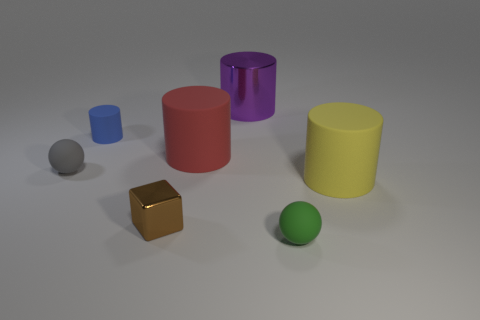Subtract all yellow cylinders. How many cylinders are left? 3 Add 1 gray matte balls. How many objects exist? 8 Subtract 2 cylinders. How many cylinders are left? 2 Subtract all spheres. How many objects are left? 5 Subtract all yellow blocks. Subtract all cyan cylinders. How many blocks are left? 1 Subtract all gray cubes. How many purple cylinders are left? 1 Subtract all small purple metallic objects. Subtract all large metal things. How many objects are left? 6 Add 7 small gray balls. How many small gray balls are left? 8 Add 6 brown rubber balls. How many brown rubber balls exist? 6 Subtract all red cylinders. How many cylinders are left? 3 